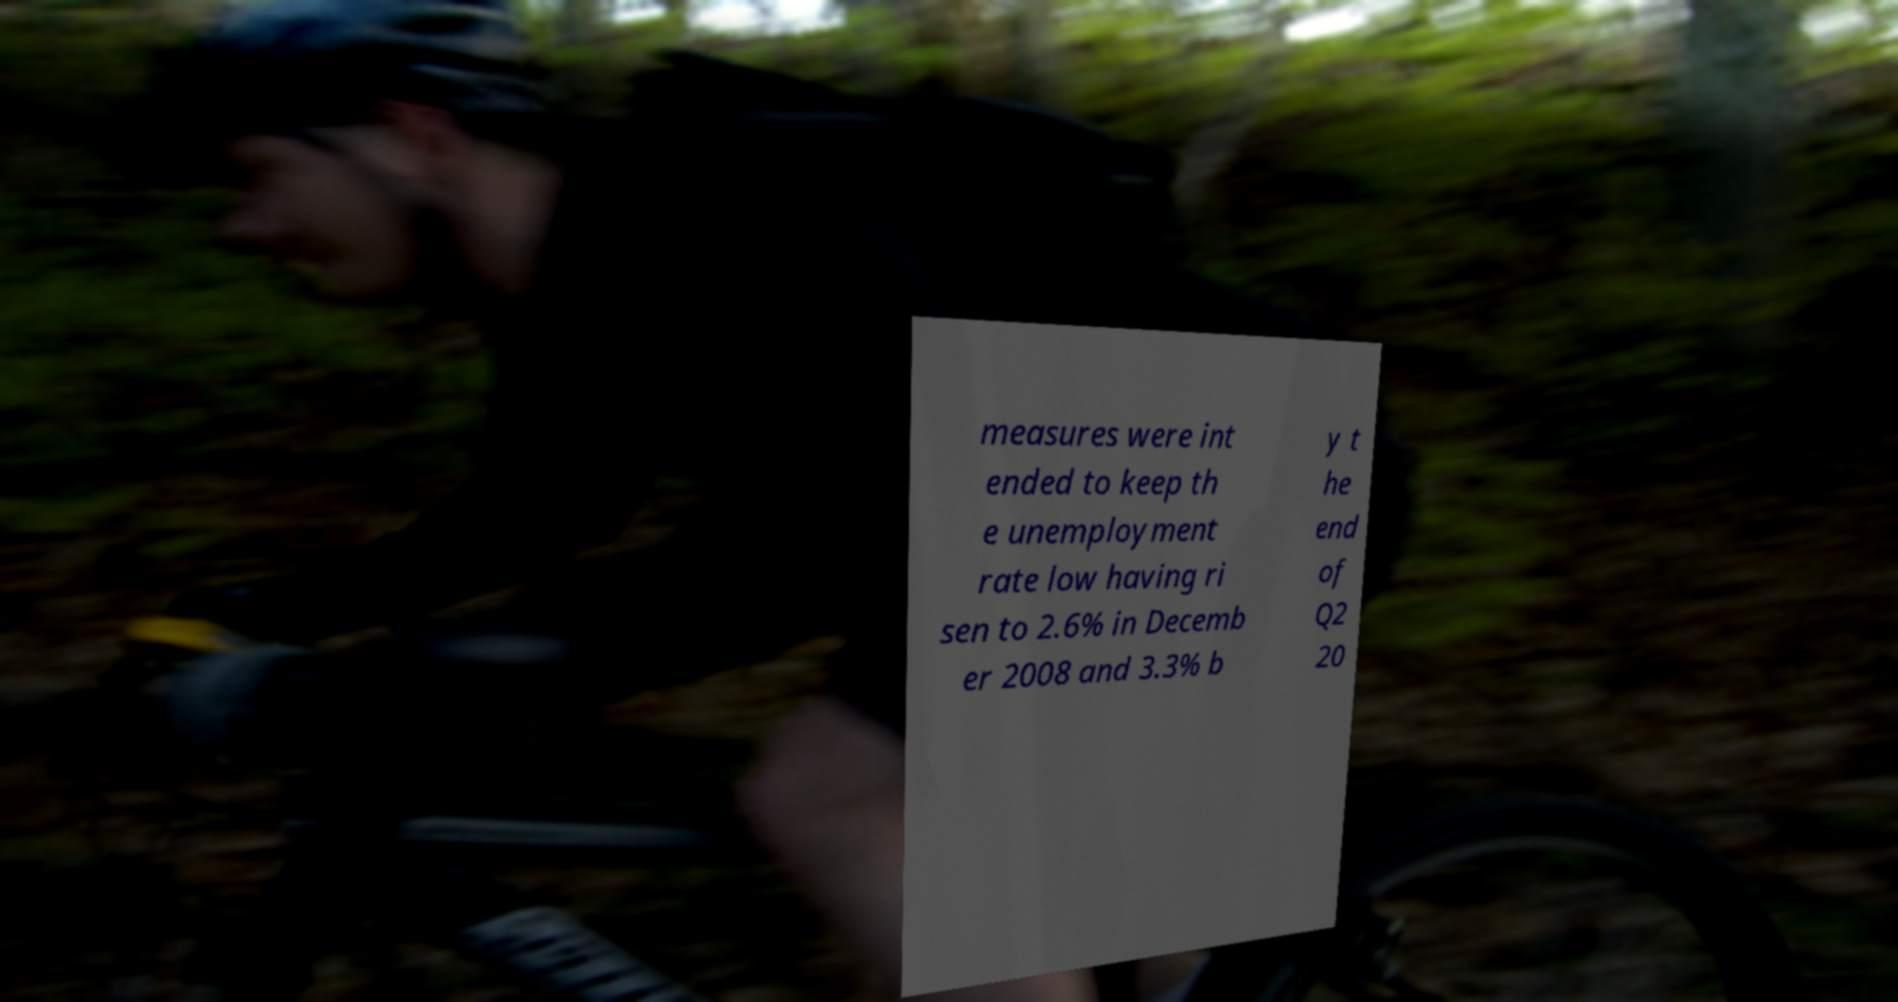Can you read and provide the text displayed in the image?This photo seems to have some interesting text. Can you extract and type it out for me? measures were int ended to keep th e unemployment rate low having ri sen to 2.6% in Decemb er 2008 and 3.3% b y t he end of Q2 20 